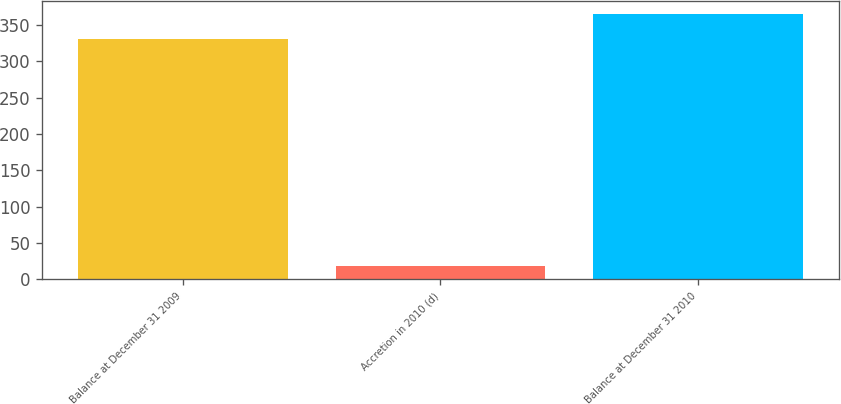Convert chart. <chart><loc_0><loc_0><loc_500><loc_500><bar_chart><fcel>Balance at December 31 2009<fcel>Accretion in 2010 (d)<fcel>Balance at December 31 2010<nl><fcel>331<fcel>19<fcel>365.4<nl></chart> 